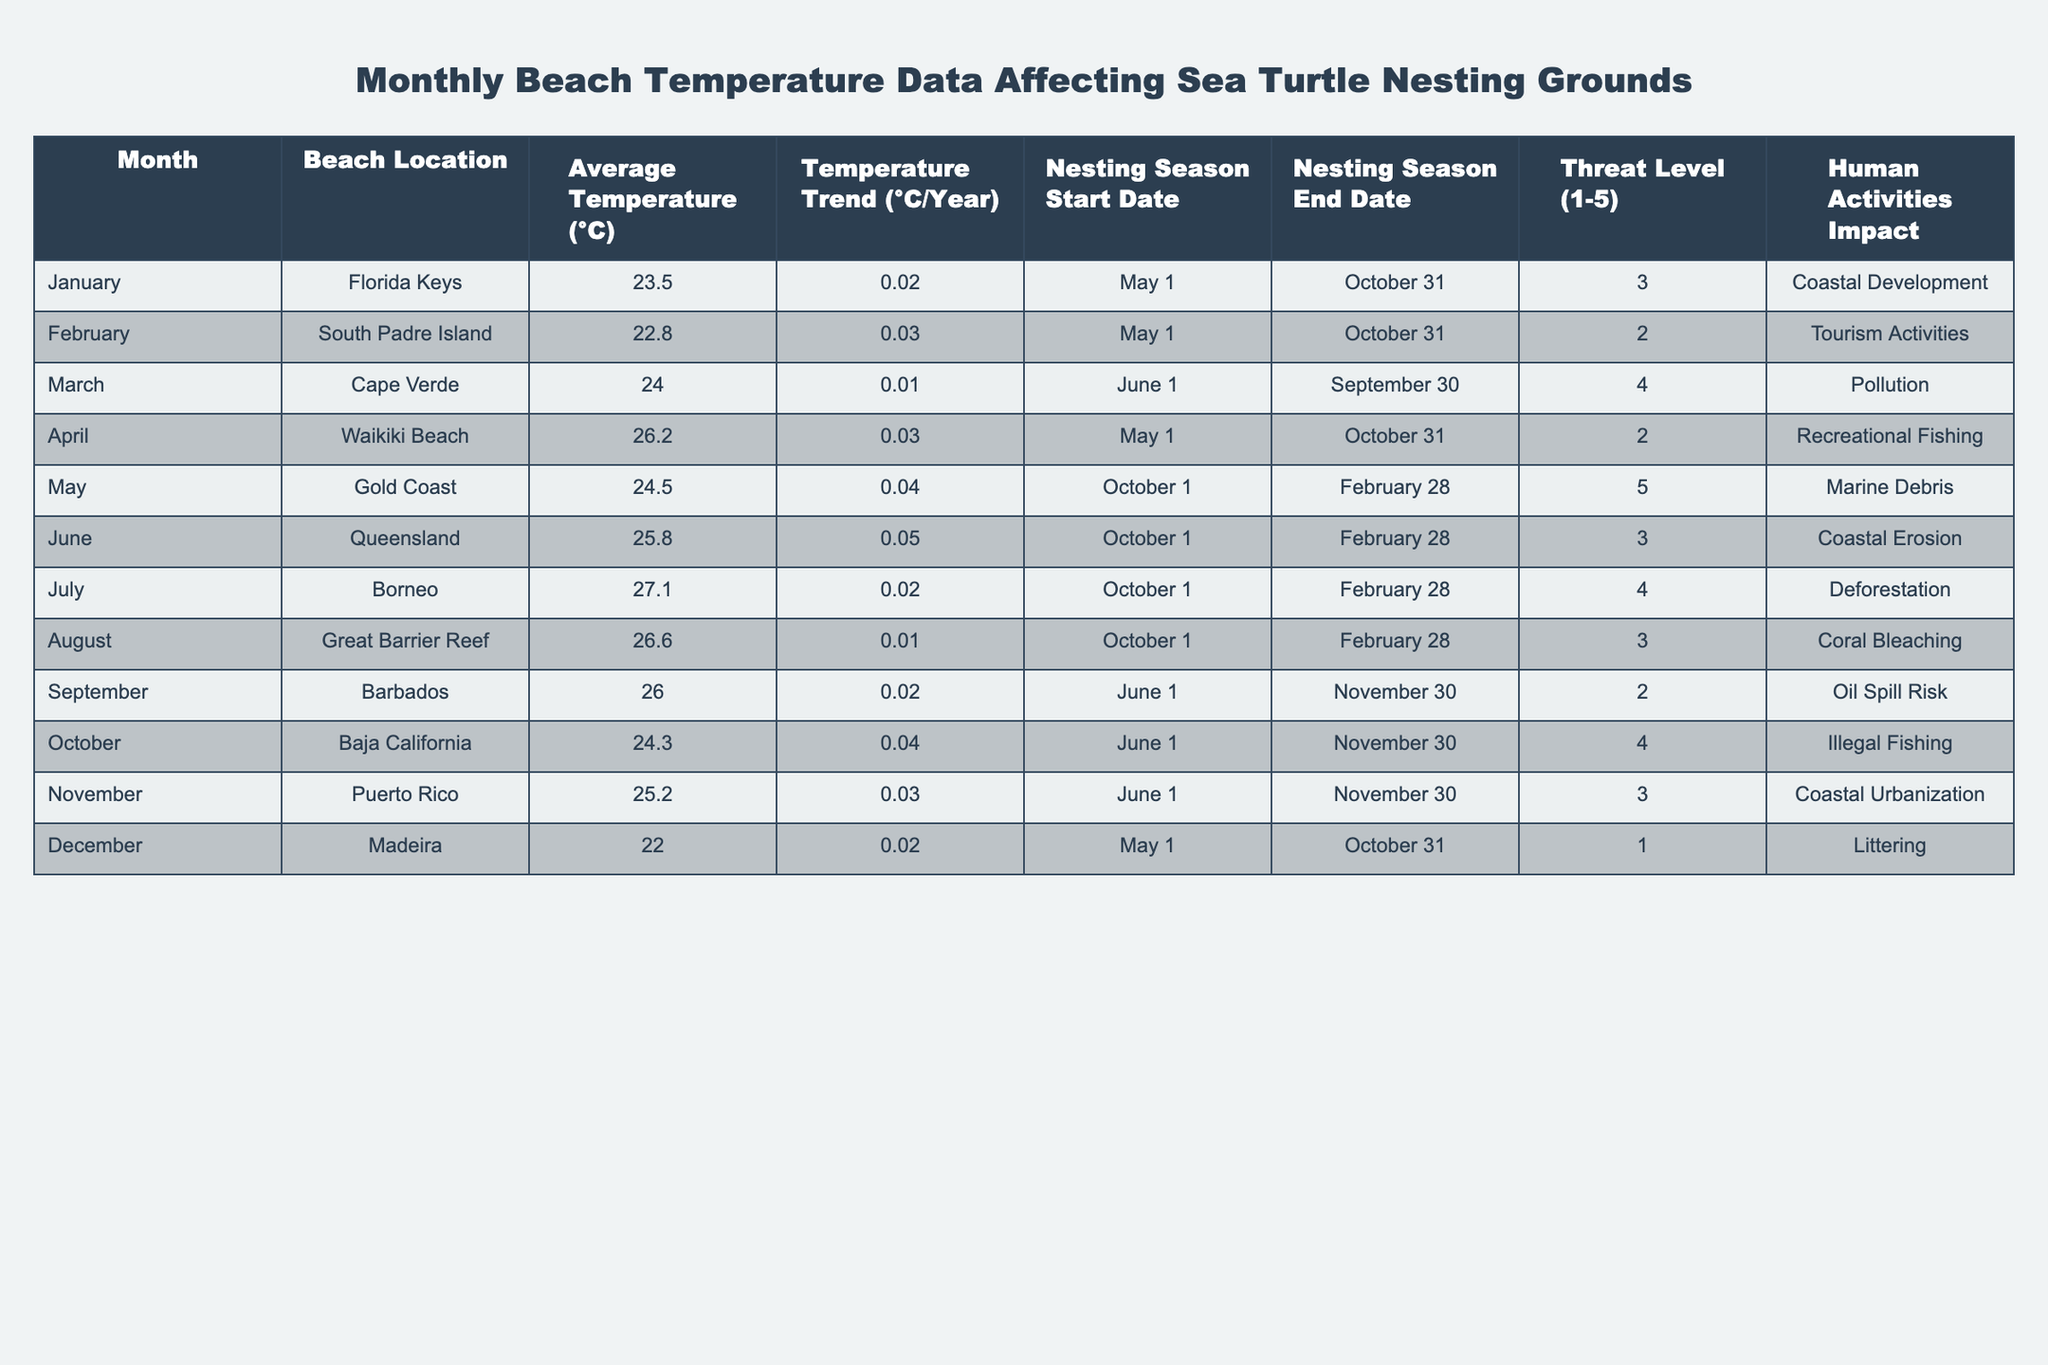What is the average temperature in July? The table shows that the average temperature for July is 27.1°C.
Answer: 27.1°C Which beach location has the highest threat level? By reviewing the "Threat Level" column, the beach with the highest threat level is the Gold Coast with a level of 5.
Answer: Gold Coast What is the temperature trend for December? The table indicates that the temperature trend for December is 0.02°C/Year.
Answer: 0.02°C/Year Do all locations have a nesting season that starts in May? Upon examining the "Nesting Season Start Date" column, not all locations start nesting in May; only Florida Keys, Waikiki Beach, and Madeira do.
Answer: No Which beach location reported a temperature trend of 0.05°C per year? Inspecting the "Temperature Trend" column reveals that Queensland has a temperature trend of 0.05°C/Year.
Answer: Queensland Is the average temperature for Puerto Rico higher than the average temperature for Florida Keys? Comparing the average temperatures, Puerto Rico has 25.2°C while Florida Keys has 23.5°C; therefore, Puerto Rico is higher.
Answer: Yes What are the nesting season end dates for locations with a threat level of 3? Reviewing the "Nesting Season End Date" for threat levels of 3 shows: Florida Keys (October 31), Queensland (February 28), and Puerto Rico (November 30).
Answer: October 31, February 28, November 30 What is the difference in average temperature between the highest and lowest temperatures recorded in the table? The highest average temperature is 27.1°C (Borneo) and the lowest is 22.0°C (Madeira). The difference is 27.1°C - 22.0°C = 5.1°C.
Answer: 5.1°C Which two locations have the same nesting season start date? By checking the "Nesting Season Start Date", both Barbados and Baja California start their nesting seasons on June 1.
Answer: Barbados and Baja California Are human activities impacting all beach locations? The "Human Activities Impact" column shows that every location has a recorded impact, confirming that all are affected by human activities.
Answer: Yes 